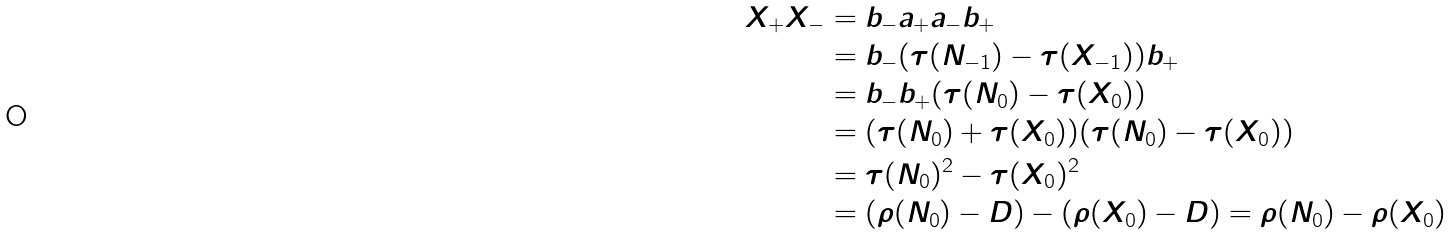Convert formula to latex. <formula><loc_0><loc_0><loc_500><loc_500>X _ { + } X _ { - } & = b _ { - } a _ { + } a _ { - } b _ { + } \\ & = b _ { - } ( \tau ( N _ { - 1 } ) - \tau ( X _ { - 1 } ) ) b _ { + } \\ & = b _ { - } b _ { + } ( \tau ( N _ { 0 } ) - \tau ( X _ { 0 } ) ) \\ & = ( \tau ( N _ { 0 } ) + \tau ( X _ { 0 } ) ) ( \tau ( N _ { 0 } ) - \tau ( X _ { 0 } ) ) \\ & = \tau ( N _ { 0 } ) ^ { 2 } - \tau ( X _ { 0 } ) ^ { 2 } \\ & = ( \rho ( N _ { 0 } ) - D ) - ( \rho ( X _ { 0 } ) - D ) = \rho ( N _ { 0 } ) - \rho ( X _ { 0 } )</formula> 